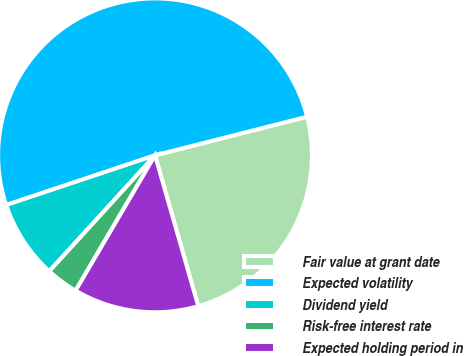Convert chart to OTSL. <chart><loc_0><loc_0><loc_500><loc_500><pie_chart><fcel>Fair value at grant date<fcel>Expected volatility<fcel>Dividend yield<fcel>Risk-free interest rate<fcel>Expected holding period in<nl><fcel>24.52%<fcel>51.17%<fcel>8.1%<fcel>3.32%<fcel>12.89%<nl></chart> 